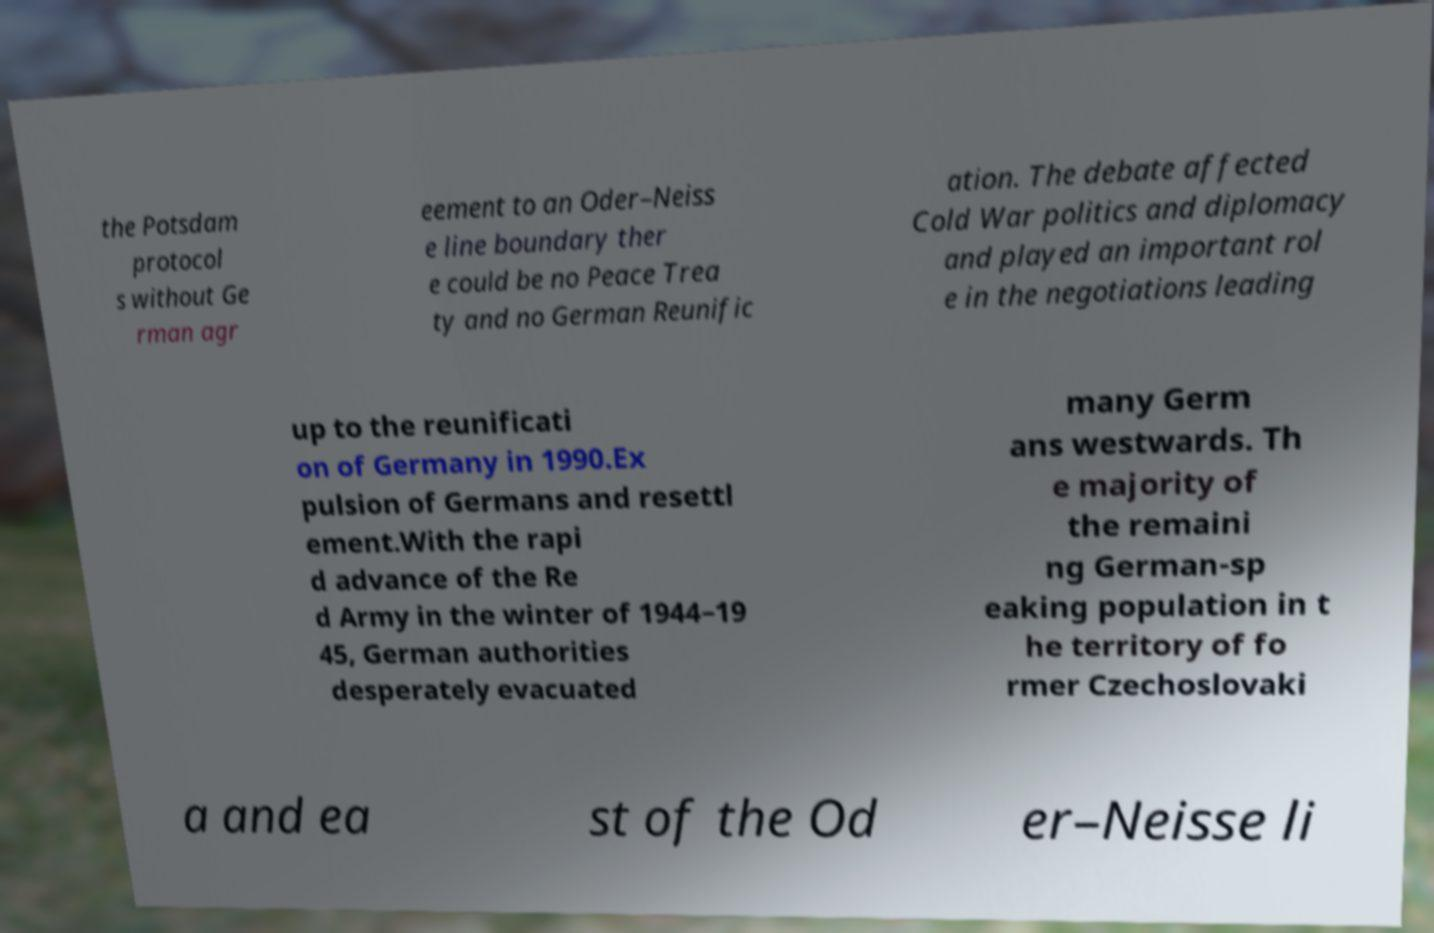Can you accurately transcribe the text from the provided image for me? the Potsdam protocol s without Ge rman agr eement to an Oder–Neiss e line boundary ther e could be no Peace Trea ty and no German Reunific ation. The debate affected Cold War politics and diplomacy and played an important rol e in the negotiations leading up to the reunificati on of Germany in 1990.Ex pulsion of Germans and resettl ement.With the rapi d advance of the Re d Army in the winter of 1944–19 45, German authorities desperately evacuated many Germ ans westwards. Th e majority of the remaini ng German-sp eaking population in t he territory of fo rmer Czechoslovaki a and ea st of the Od er–Neisse li 